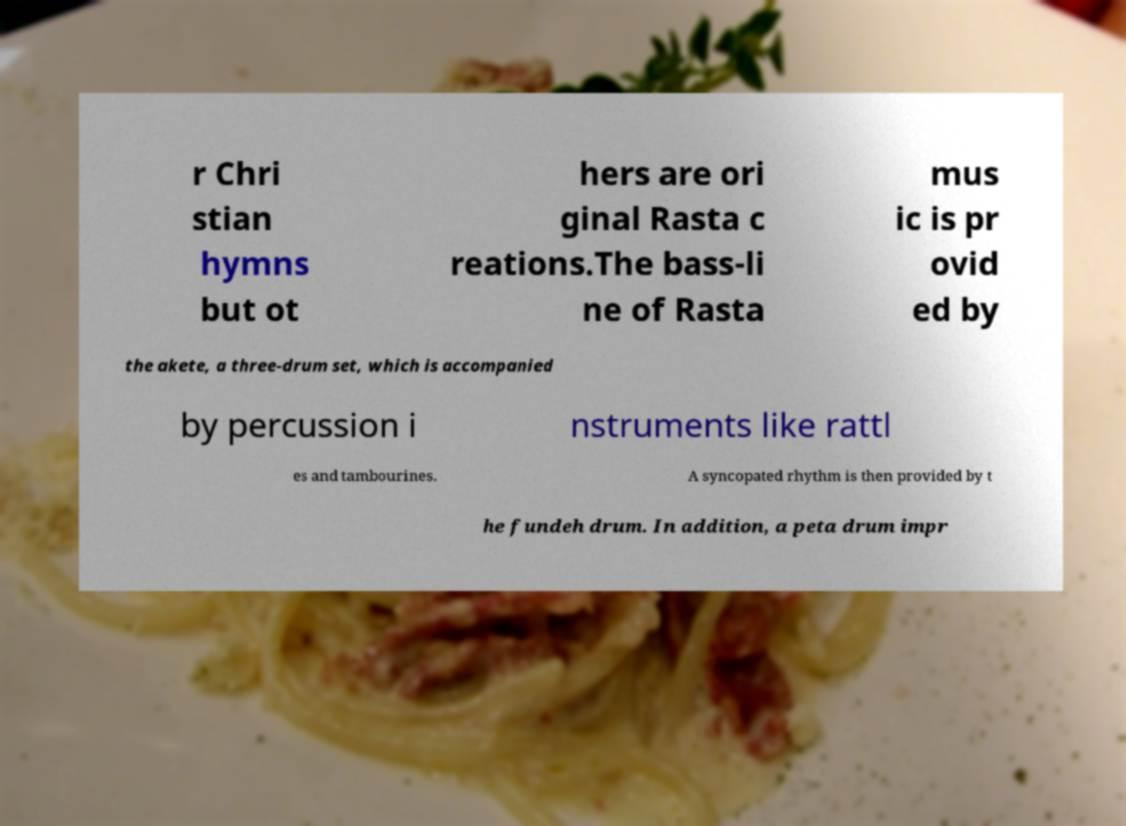I need the written content from this picture converted into text. Can you do that? r Chri stian hymns but ot hers are ori ginal Rasta c reations.The bass-li ne of Rasta mus ic is pr ovid ed by the akete, a three-drum set, which is accompanied by percussion i nstruments like rattl es and tambourines. A syncopated rhythm is then provided by t he fundeh drum. In addition, a peta drum impr 